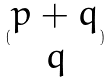<formula> <loc_0><loc_0><loc_500><loc_500>( \begin{matrix} p + q \\ q \end{matrix} )</formula> 